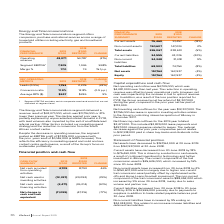According to Iselect's financial document, What is the percentage change in current assets from 2018 to 2019? According to the financial document, 18%. The relevant text states: "Current assets 75,460 91,457 (18%)..." Also, What is the primary cause of the decrease in the current liabilities? due to payments to suppliers in addition to trade related payable balances post 30 June 2018. The document states: "8 to 30 June 2019 by 20% to $34,555,000 primarily due to payments to suppliers in addition to trade related payable balances post 30 June 2018...." Also, What contributed to the increase in non-current liabilities in 2019? an increase in lease liabilities and deferred tax liabilities. The document states: "ased by 9% ending on $34,348,000. This relates to an increase in lease liabilities and deferred tax liabilities...." Also, can you calculate: What is the current ratio in 2019? Based on the calculation: 75,460/34,555, the result is 2.18. This is based on the information: "Current assets 75,460 91,457 (18%) Current liabilities 34,555 43,336 (20%)..." The key data points involved are: 34,555, 75,460. Also, can you calculate: What is the debts to assets ratio in 2019? Based on the calculation: 68,903/226,067, the result is 0.3. This is based on the information: "Total liabilities 68,903 74,754 (8%) Total assets 226,067 238,691 (5%)..." The key data points involved are: 226,067, 68,903. Also, can you calculate: What is the percentage change in the net assets from 2018 to 2019? To answer this question, I need to perform calculations using the financial data. The calculation is: (157,164-163,937)/163,937, which equals -4.13 (percentage). This is based on the information: "Net assets 157,164 163,937 (4%) Net assets 157,164 163,937 (4%)..." The key data points involved are: 157,164, 163,937. 